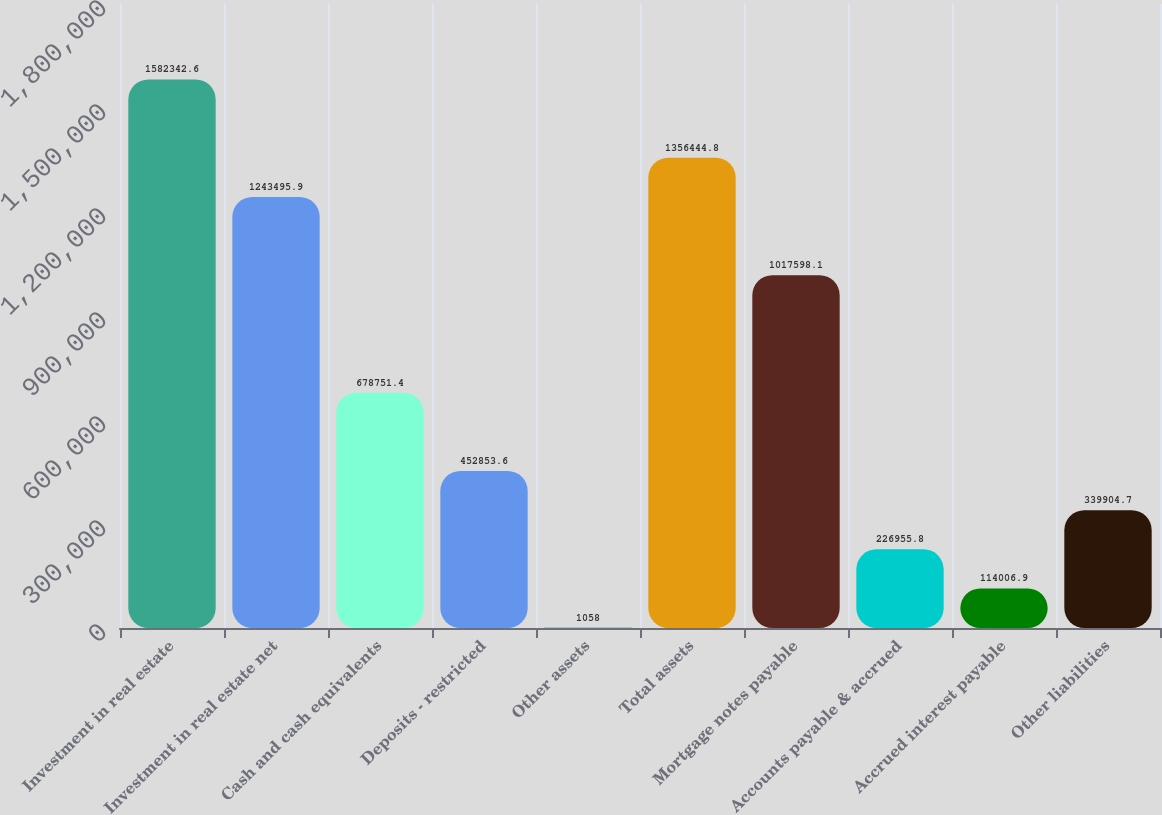<chart> <loc_0><loc_0><loc_500><loc_500><bar_chart><fcel>Investment in real estate<fcel>Investment in real estate net<fcel>Cash and cash equivalents<fcel>Deposits - restricted<fcel>Other assets<fcel>Total assets<fcel>Mortgage notes payable<fcel>Accounts payable & accrued<fcel>Accrued interest payable<fcel>Other liabilities<nl><fcel>1.58234e+06<fcel>1.2435e+06<fcel>678751<fcel>452854<fcel>1058<fcel>1.35644e+06<fcel>1.0176e+06<fcel>226956<fcel>114007<fcel>339905<nl></chart> 